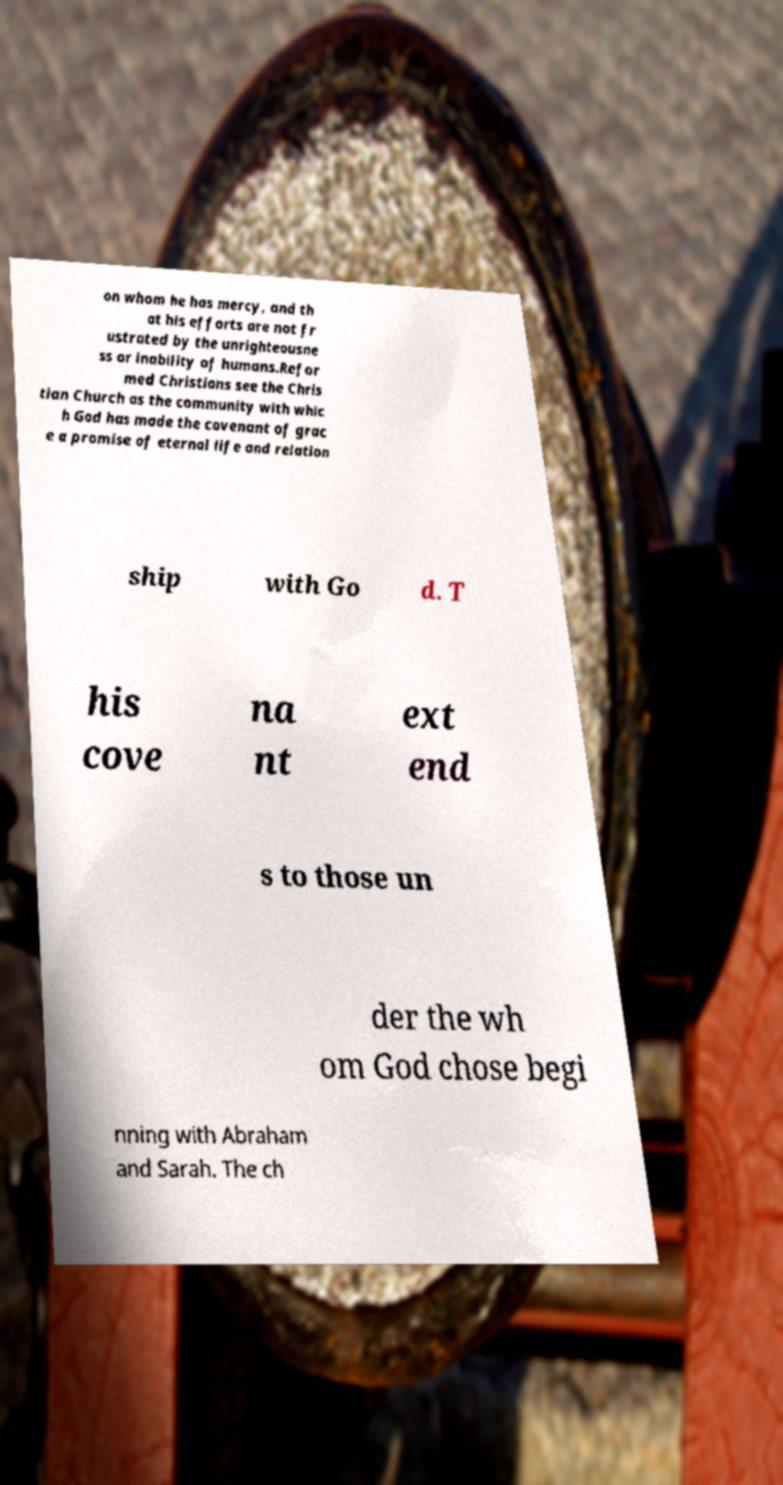Can you accurately transcribe the text from the provided image for me? on whom he has mercy, and th at his efforts are not fr ustrated by the unrighteousne ss or inability of humans.Refor med Christians see the Chris tian Church as the community with whic h God has made the covenant of grac e a promise of eternal life and relation ship with Go d. T his cove na nt ext end s to those un der the wh om God chose begi nning with Abraham and Sarah. The ch 